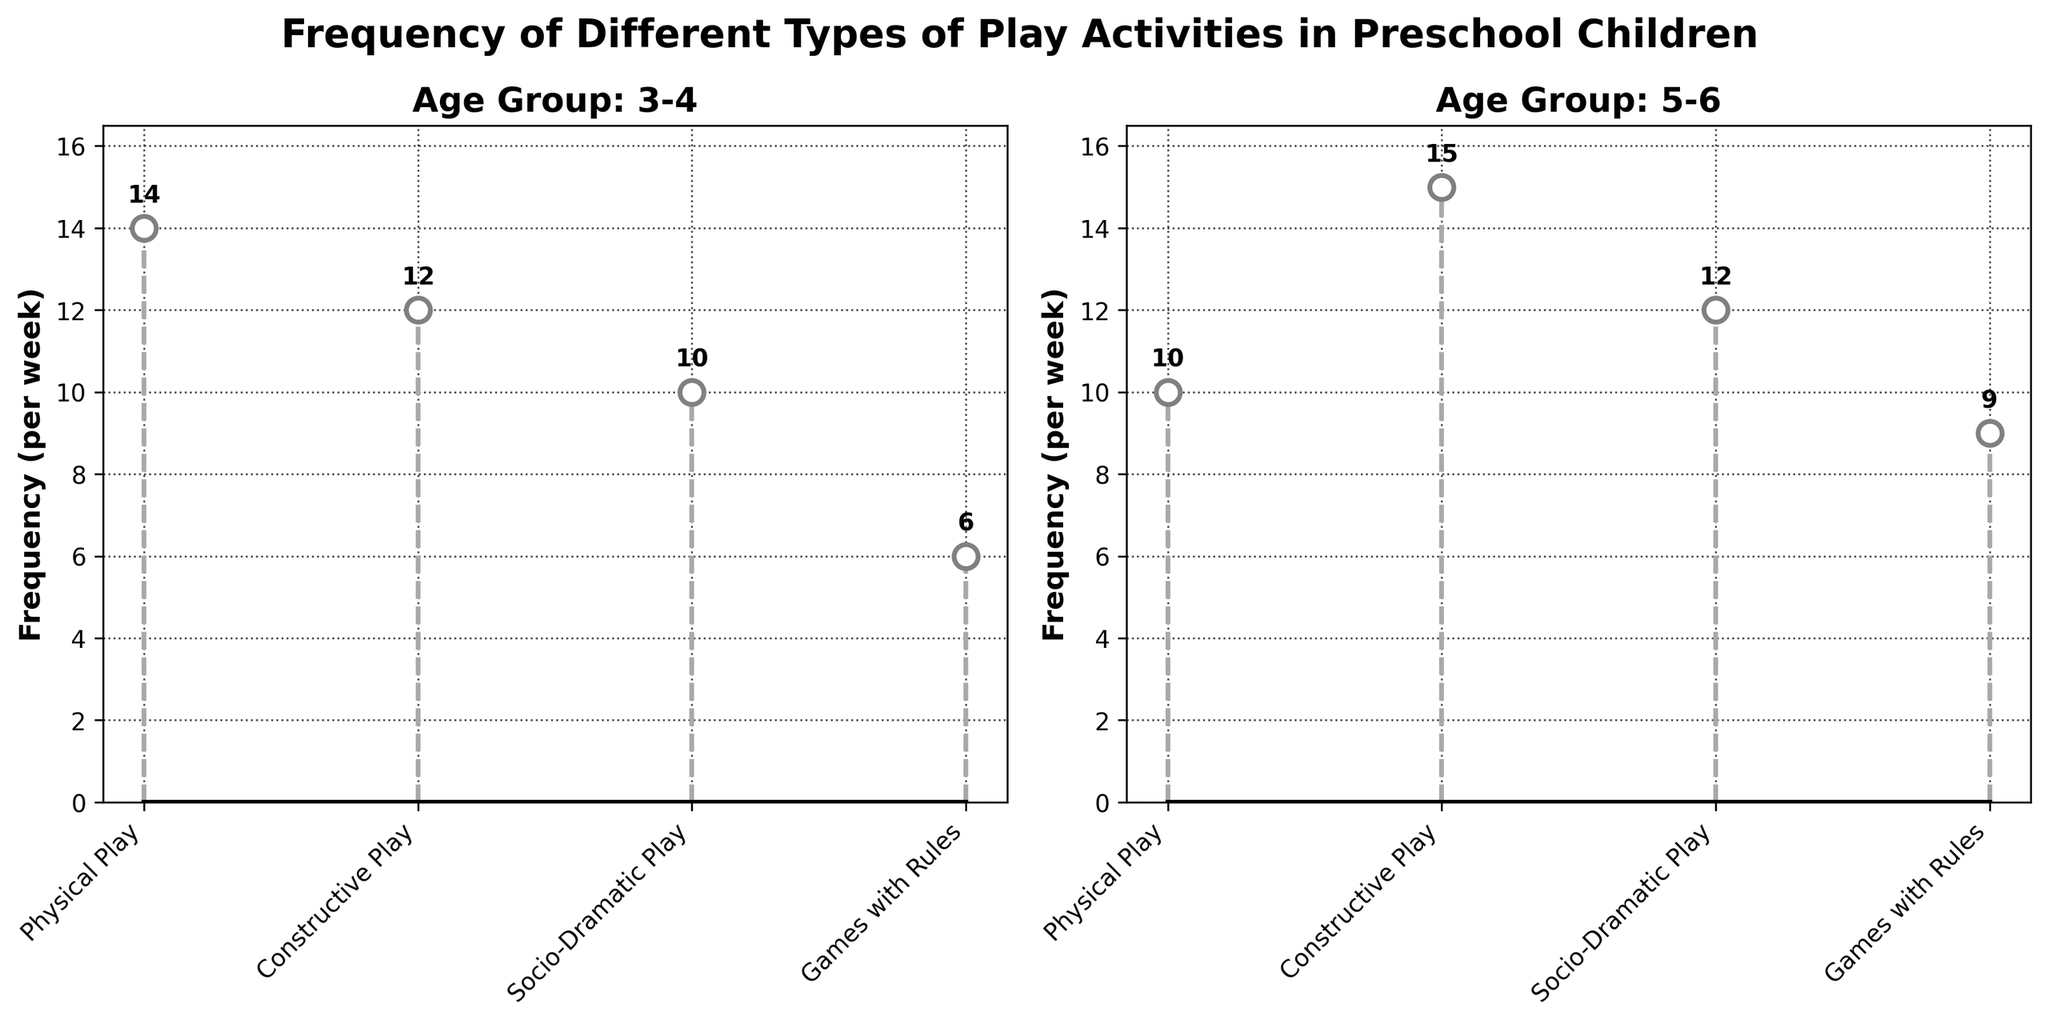What is the highest frequency of Constructive Play in the figure? For the age group 5-6, Constructive Play has the highest frequency, which is represented by the highest point in the Constructive Play stem.
Answer: 15 Which age group has a higher frequency of Socio-Dramatic Play? Compare the frequencies of Socio-Dramatic Play in the age groups 3-4 and 5-6. The age group 5-6 has a frequency of 12, while the age group 3-4 has a frequency of 10.
Answer: 5-6 What is the total frequency of Play Activities for the age group 3-4? Add up the frequencies of all types of play for the age group 3-4: Physical Play (14) + Constructive Play (12) + Socio-Dramatic Play (10) + Games with Rules (6) = 42.
Answer: 42 Which type of play has the lowest frequency in the age group 3-4? In the age group 3-4, Games with Rules has the lowest frequency as shown by the shortest stem in this plot segment.
Answer: Games with Rules By how much does the frequency of Games with Rules increase from the age group 3-4 to 5-6? Calculate the difference in the frequencies of Games with Rules between age groups: 9 (age group 5-6) - 6 (age group 3-4) = 3.
Answer: 3 Which type of play exhibits an increase in frequency as children age from 3-4 to 5-6? Compare the frequencies of each type of play between the age groups and identify those that show an increase: Games with Rules (6 to 9) and Constructive Play (12 to 15).
Answer: Games with Rules, Constructive Play What is the average frequency of Physical Play across both age groups? Calculate the average of the frequencies for Physical Play: (14 (age group 3-4) + 10 (age group 5-6)) / 2 = 12.
Answer: 12 If we sum the frequencies for Socio-Dramatic Play across both age groups, what value do we get? Add the frequencies of Socio-Dramatic Play for both age groups: 10 (age group 3-4) + 12 (age group 5-6) = 22.
Answer: 22 How many types of play are compared in each subplot? Count the different stems in each subplot, which correspond to the play types. There are four play types in each subplot (Physical Play, Constructive Play, Socio-Dramatic Play, Games with Rules).
Answer: 4 